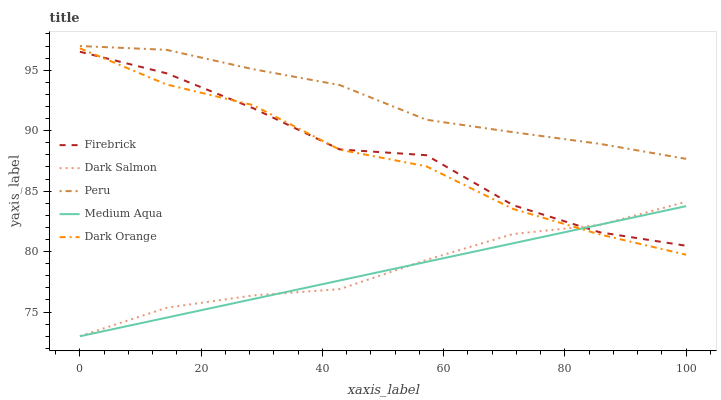Does Medium Aqua have the minimum area under the curve?
Answer yes or no. Yes. Does Peru have the maximum area under the curve?
Answer yes or no. Yes. Does Firebrick have the minimum area under the curve?
Answer yes or no. No. Does Firebrick have the maximum area under the curve?
Answer yes or no. No. Is Medium Aqua the smoothest?
Answer yes or no. Yes. Is Firebrick the roughest?
Answer yes or no. Yes. Is Firebrick the smoothest?
Answer yes or no. No. Is Medium Aqua the roughest?
Answer yes or no. No. Does Medium Aqua have the lowest value?
Answer yes or no. Yes. Does Firebrick have the lowest value?
Answer yes or no. No. Does Peru have the highest value?
Answer yes or no. Yes. Does Firebrick have the highest value?
Answer yes or no. No. Is Firebrick less than Peru?
Answer yes or no. Yes. Is Peru greater than Dark Orange?
Answer yes or no. Yes. Does Dark Orange intersect Dark Salmon?
Answer yes or no. Yes. Is Dark Orange less than Dark Salmon?
Answer yes or no. No. Is Dark Orange greater than Dark Salmon?
Answer yes or no. No. Does Firebrick intersect Peru?
Answer yes or no. No. 